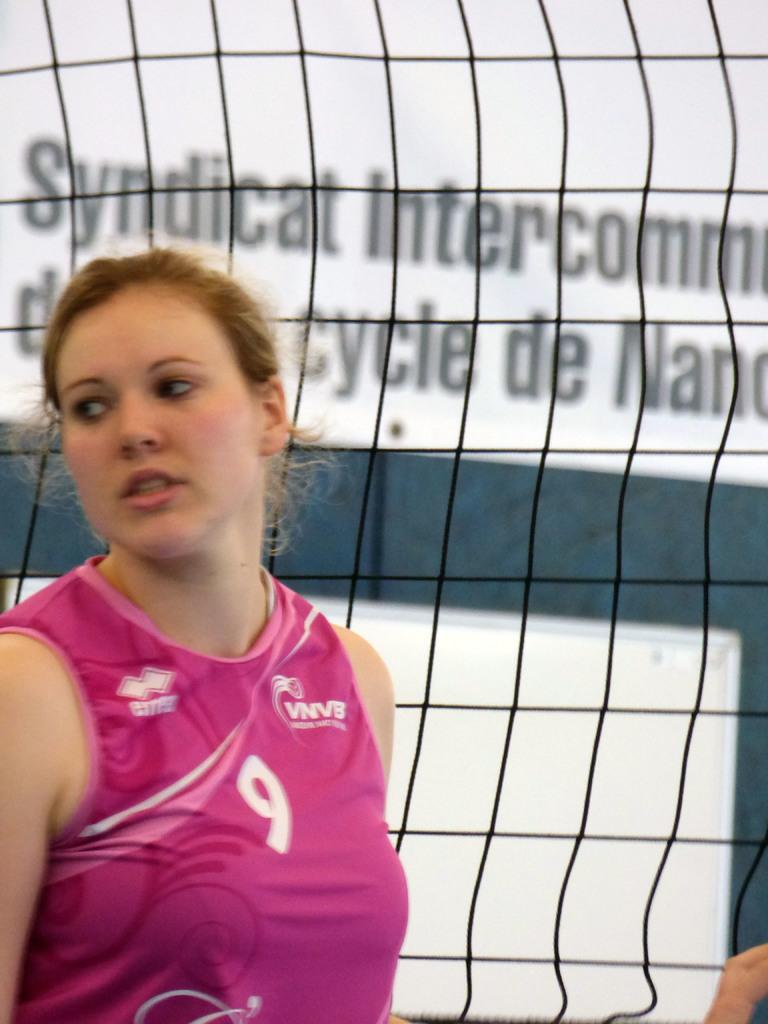<image>
Create a compact narrative representing the image presented. The poster behind the girl talks about a syndicat. 